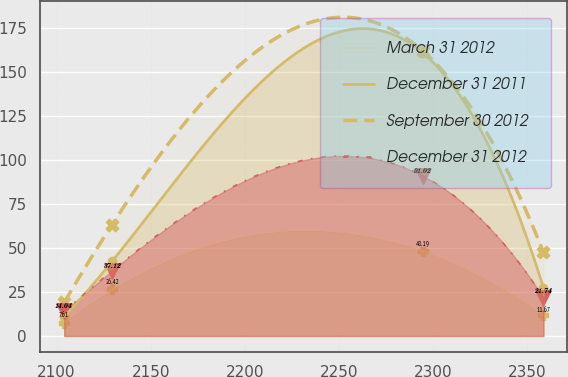<chart> <loc_0><loc_0><loc_500><loc_500><line_chart><ecel><fcel>March 31 2012<fcel>December 31 2011<fcel>September 30 2012<fcel>December 31 2012<nl><fcel>2104.03<fcel>7.61<fcel>11.07<fcel>19.11<fcel>14.04<nl><fcel>2129.52<fcel>26.42<fcel>42.46<fcel>63.33<fcel>37.12<nl><fcel>2294.64<fcel>48.19<fcel>160.96<fcel>162.02<fcel>91.02<nl><fcel>2358.89<fcel>11.67<fcel>27.47<fcel>47.45<fcel>21.74<nl></chart> 